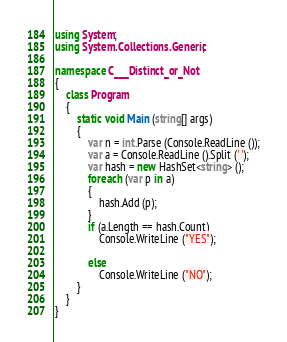Convert code to text. <code><loc_0><loc_0><loc_500><loc_500><_C#_>using System;
using System.Collections.Generic;

namespace C___Distinct_or_Not
{
    class Program
    {
        static void Main (string[] args)
        {
            var n = int.Parse (Console.ReadLine ());
            var a = Console.ReadLine ().Split (' ');
            var hash = new HashSet<string> ();
            foreach (var p in a)
            {
                hash.Add (p);
            }
            if (a.Length == hash.Count)
                Console.WriteLine ("YES");

            else
                Console.WriteLine ("NO");
        }
    }
}</code> 